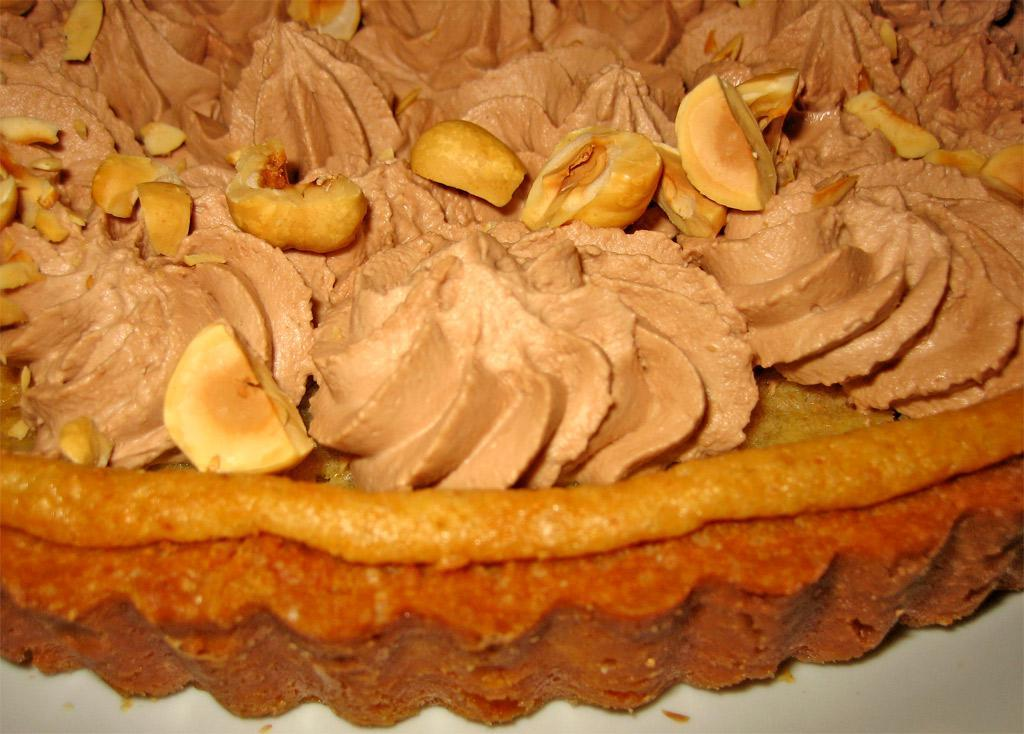What type of items can be seen in the image? The image contains food. Is there a table visible in the image? There is no mention of a table in the provided fact, so it cannot be determined if a table is visible in the image. 